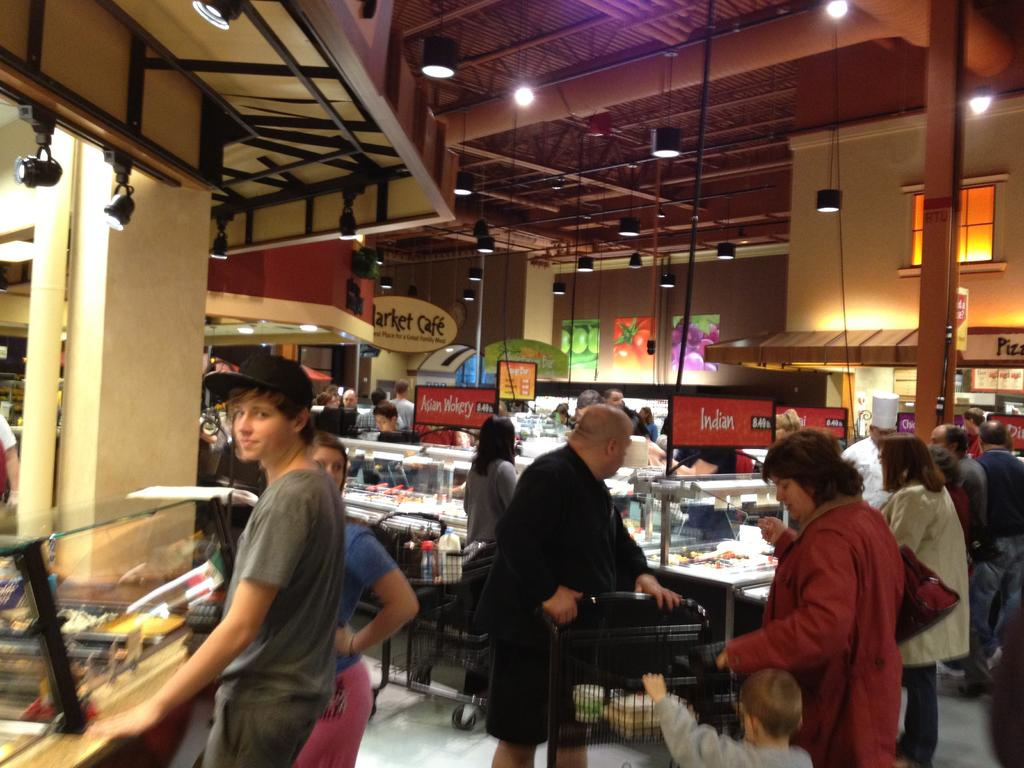What is the main subject of the image? The main subject of the image is a group of people standing. What else can be seen in the image besides the people? There are trolleys with objects, stalls, lights, iron rods, papers stuck to a wall, boards, and items in glass boxes visible in the image. How many brothers are standing together in the image? There is no information about brothers in the image, so we cannot determine the number of brothers present. 